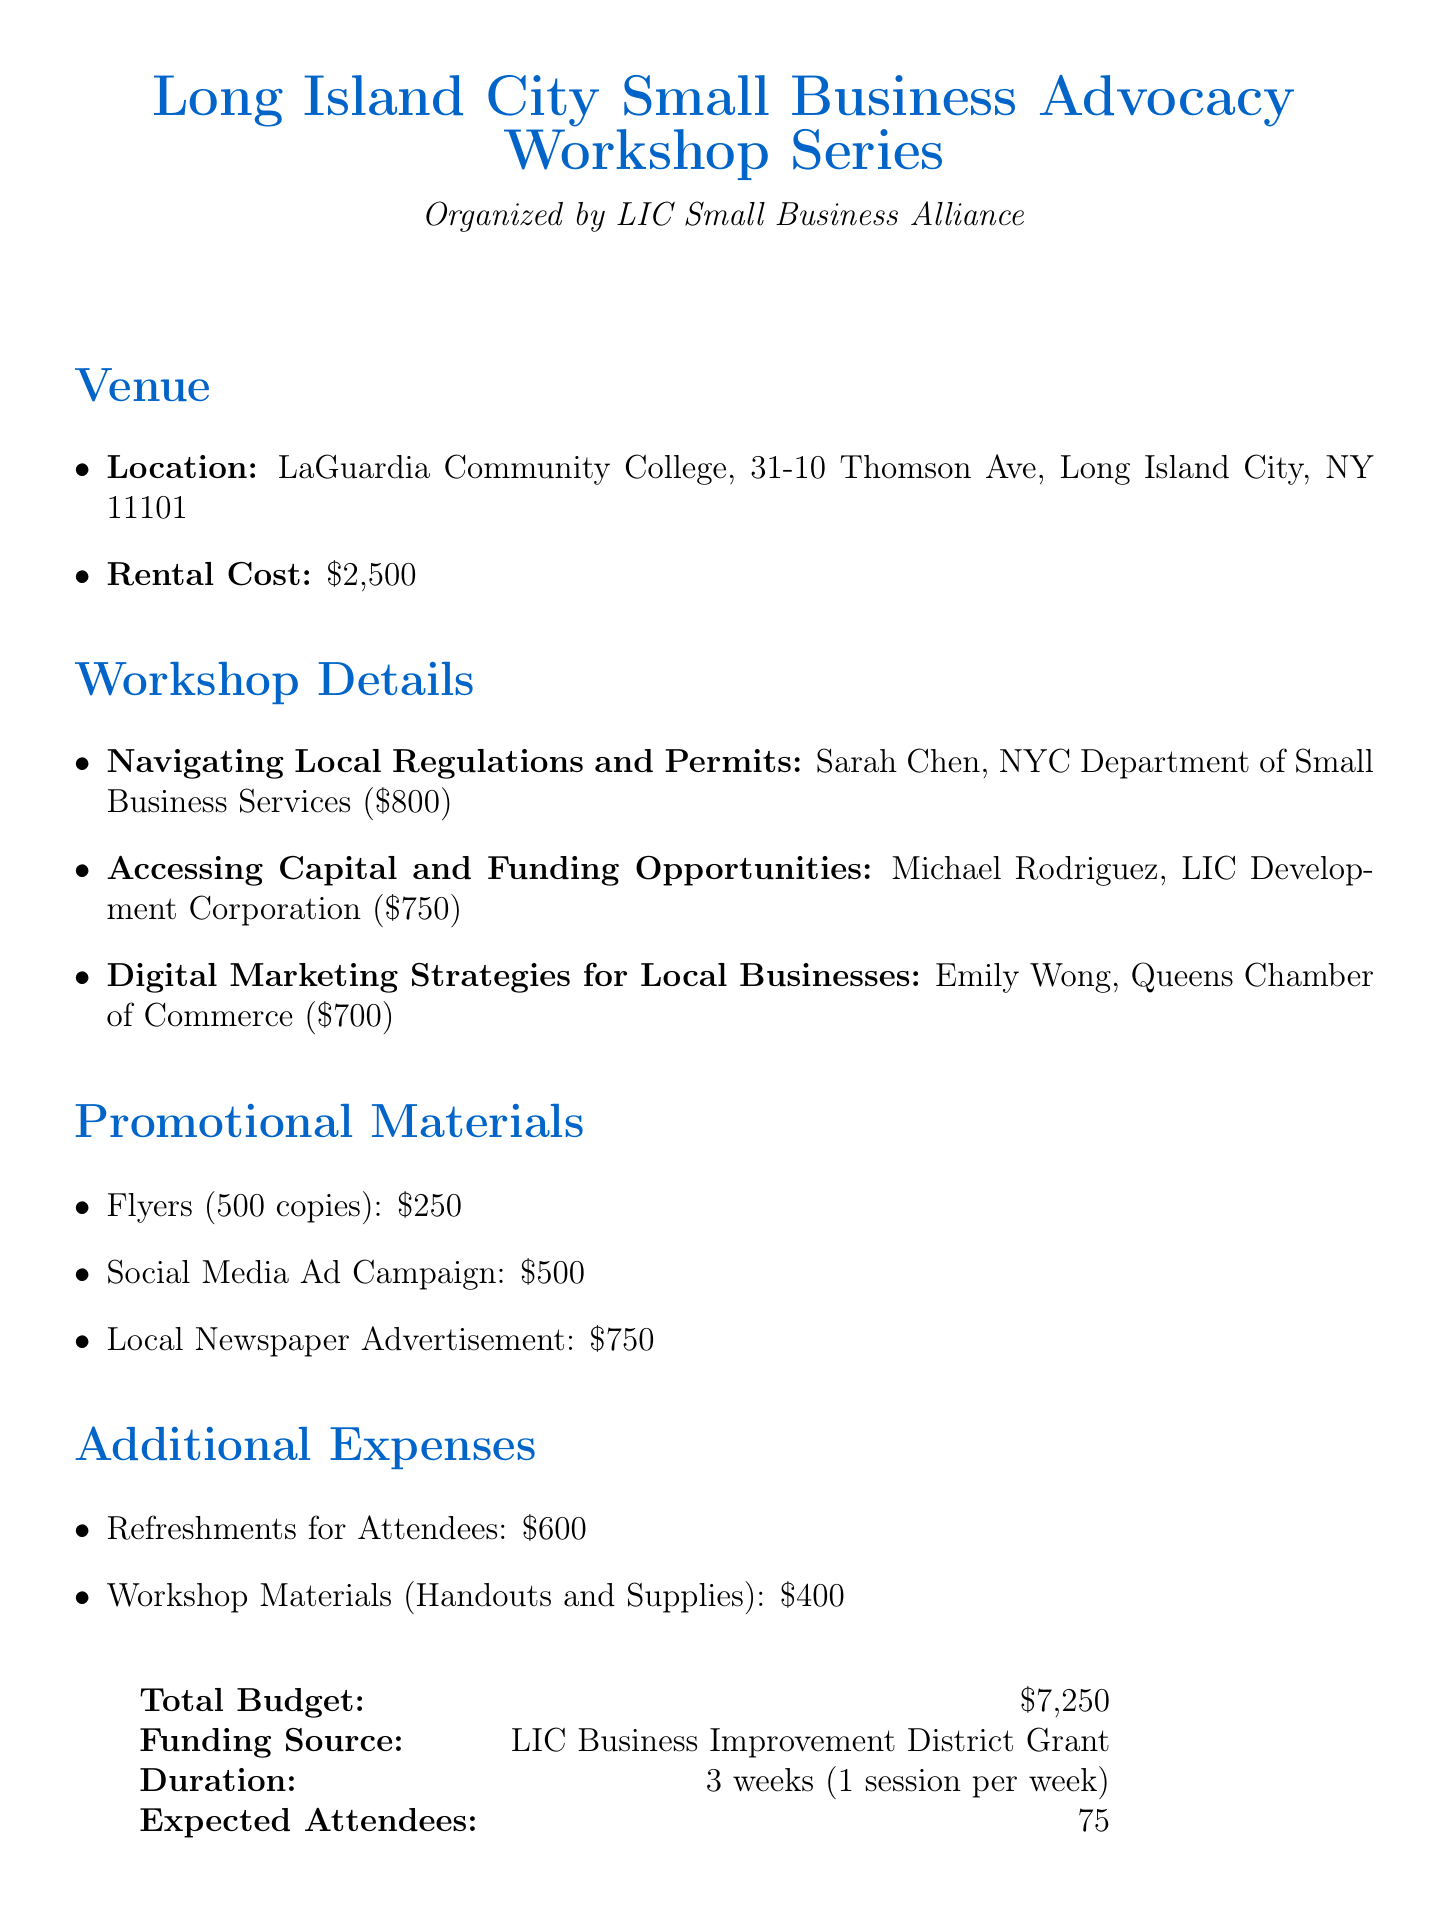What is the venue for the workshop series? The venue for the workshop series is specified in the document as LaGuardia Community College.
Answer: LaGuardia Community College What is the total budget for the workshop series? The total budget is clearly stated in the document as $7,250.
Answer: $7,250 Who is the speaker for the workshop on digital marketing strategies? The document lists Emily Wong as the speaker for digital marketing strategies for local businesses.
Answer: Emily Wong How much will be spent on promotional materials? The document specifies the costs of all promotional materials, which total to $1,500.
Answer: $1,500 How long will the workshop series last? The duration of the workshop series is mentioned as lasting for 3 weeks, with 1 session each week.
Answer: 3 weeks What are the refreshment costs for attendees? The document includes the cost for refreshments for attendees, which is $600.
Answer: $600 What is the funding source for this workshop series? The document indicates that the funding source is the LIC Business Improvement District Grant.
Answer: LIC Business Improvement District Grant What is the expected number of attendees for the series? The document specifies that the expected number of attendees is 75.
Answer: 75 How many copies of flyers will be printed? The document states that there will be 500 copies of flyers printed.
Answer: 500 copies 